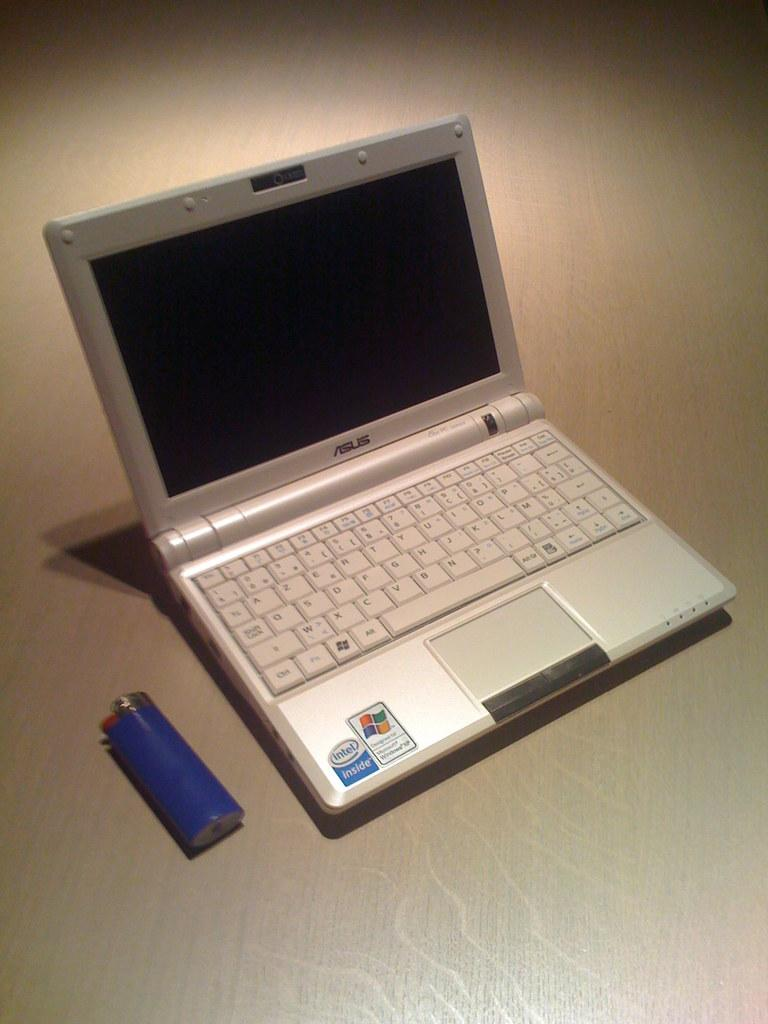What electronic device is visible in the image? There is a laptop in the image. What color is the object in the image? There is a blue color object in the image. What type of surface is present in the image? The wooden surface is present in the image. What type of fear can be seen on the face of the tiger in the image? There is no tiger present in the image, so it is not possible to determine any fear on its face. 